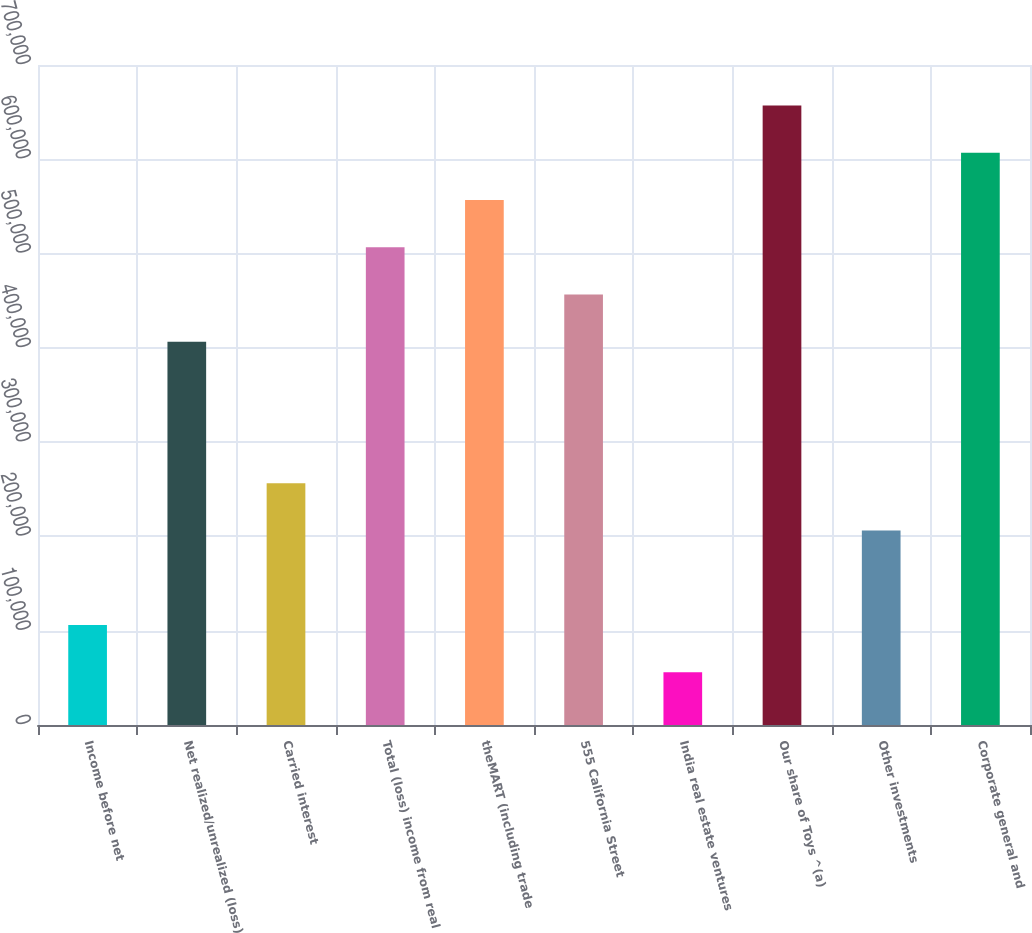Convert chart to OTSL. <chart><loc_0><loc_0><loc_500><loc_500><bar_chart><fcel>Income before net<fcel>Net realized/unrealized (loss)<fcel>Carried interest<fcel>Total (loss) income from real<fcel>theMART (including trade<fcel>555 California Street<fcel>India real estate ventures<fcel>Our share of Toys ^(a)<fcel>Other investments<fcel>Corporate general and<nl><fcel>105976<fcel>406589<fcel>256282<fcel>506794<fcel>556896<fcel>456692<fcel>55873.3<fcel>657101<fcel>206180<fcel>606999<nl></chart> 